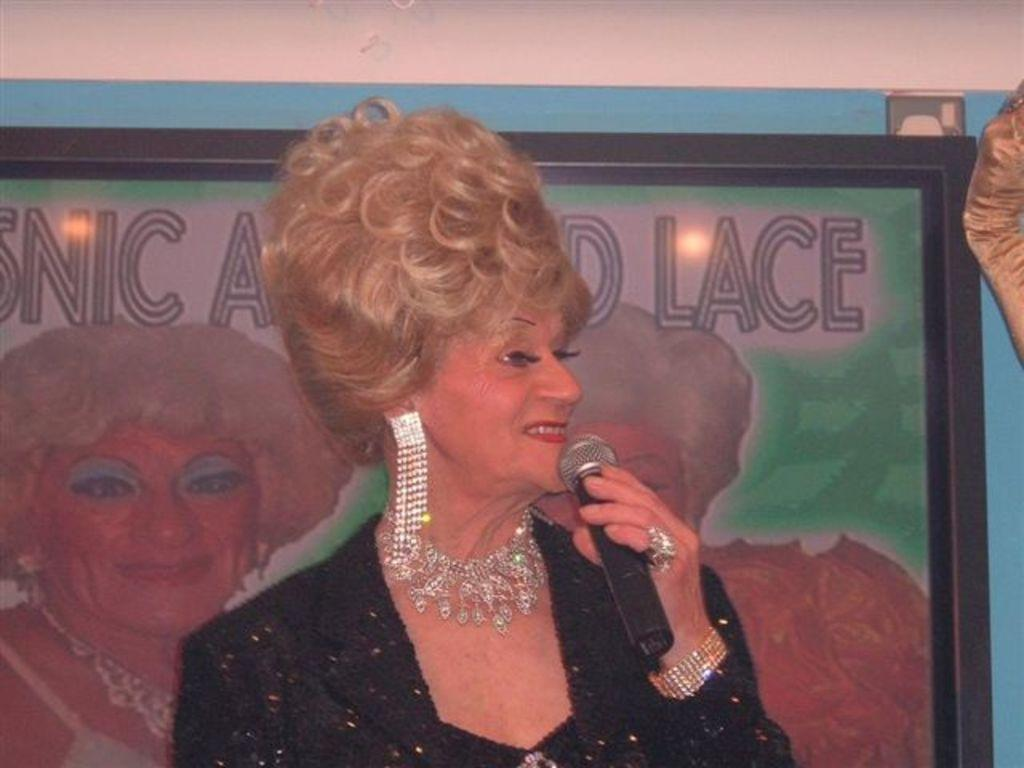What is the main subject of the image? The main subject of the image is a woman. What is the woman holding in the image? The woman is holding a microphone. What is the woman's facial expression in the image? The woman is smiling in the image. What level of difficulty is the woman's design in the image? There is no mention of a design or level of difficulty in the image; it simply shows a woman holding a microphone and smiling. 